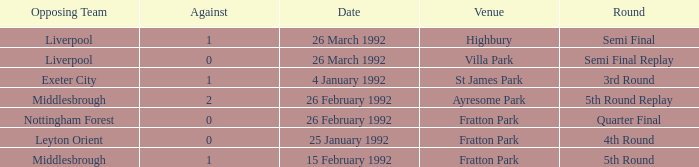What was the phase for villa park? Semi Final Replay. 